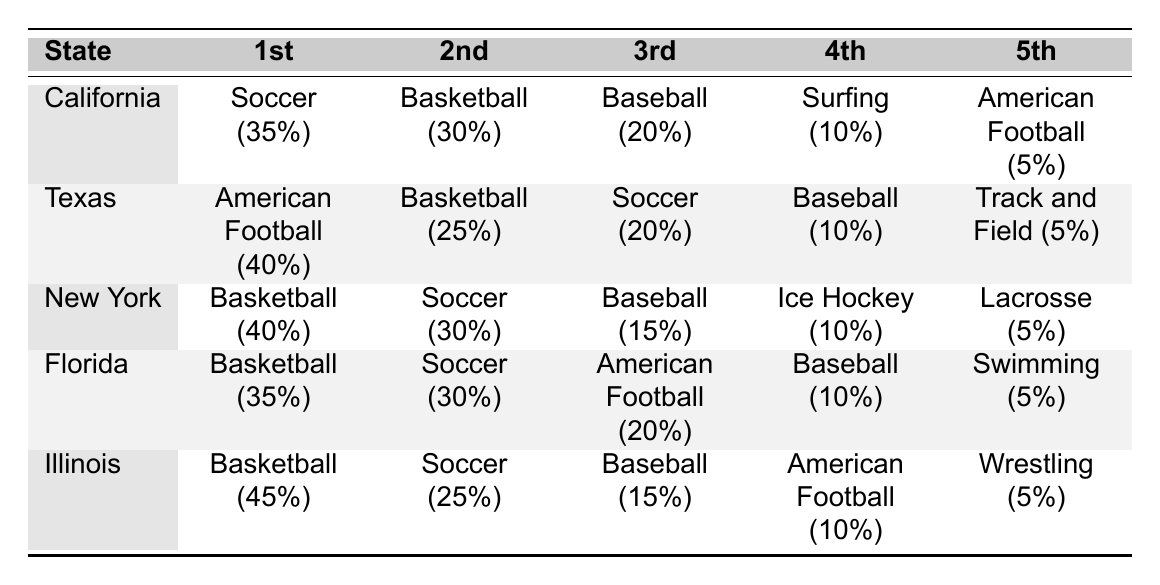What's the most popular sport activity in California? The table shows that in California, Soccer is listed as the most popular sport with a percentage of 35%.
Answer: Soccer Which state has American Football as the top sport? Looking at the table, Texas has American Football as the top sport, with a percentage of 40%.
Answer: Texas What percentage of teenage boys in Florida prefer Swimming as their favorite sport? In the table, Swimming is indicated as the least favorite sport in Florida, with only 5%.
Answer: 5% How does the popularity of Soccer in New York compare to Illinois? In New York, Soccer has a popularity of 30%, whereas in Illinois it is 25%. The difference is 5%. Thus, Soccer is more popular in New York compared to Illinois.
Answer: 5% more popular in New York What is the total percentage of teenage boys in California who prefer Baseball and American Football combined? From the table, California shows Baseball at 20% and American Football at 5%. The total percentage is 20 + 5 = 25%.
Answer: 25% Is Basketball the most popular sport across all listed states? Analyzing the table, Basketball is the most popular sport in Illinois (45%) and Florida (35%), but in California and New York, Soccer and Basketball are tied at 1st position. In Texas, American Football is the most popular sport. Therefore, Basketball is not the most popular overall.
Answer: No What is the average percentage of preference for Baseball among all states? Adding the percentages for Baseball from all states: California 20%, Texas 10%, New York 15%, Florida 10%, Illinois 15% gives us a total of 70. Dividing by 5 (the number of states) yields an average of 70/5 = 14%.
Answer: 14% Which state has the least preference for Track and Field among those listed? By checking the table, Track and Field appears only in Texas with a preference of 5%. It is the lowest among the sports given in all states, as it does not appear in any other state.
Answer: Texas In which two states is Soccer the second most popular sport? According to the table, Soccer is the second most popular sport in California (30%) and New York (30%).
Answer: California and New York 